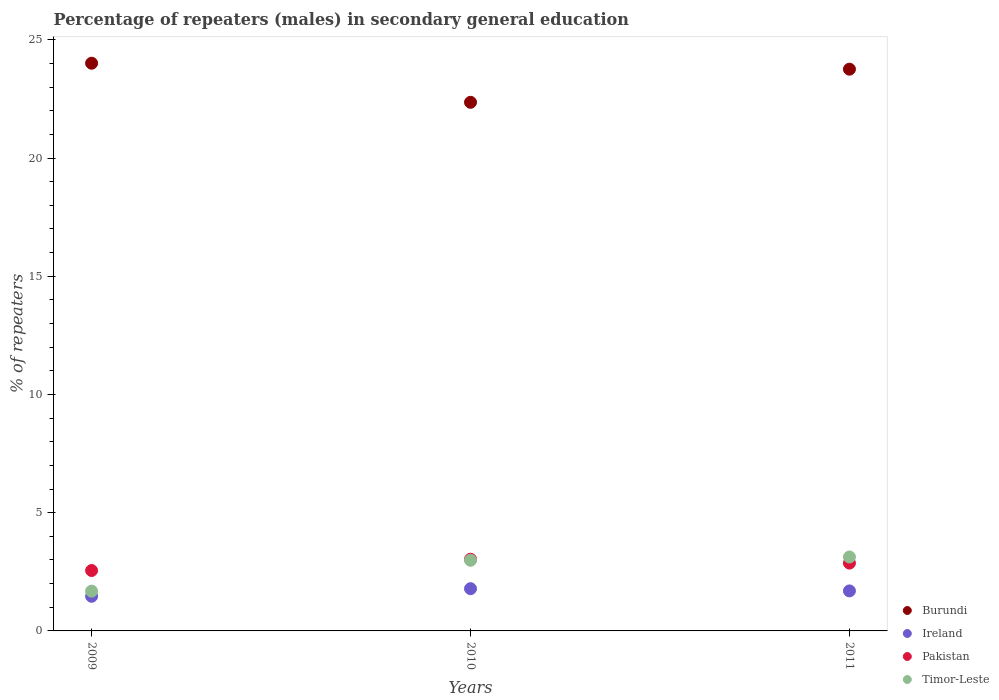How many different coloured dotlines are there?
Your answer should be very brief. 4. What is the percentage of male repeaters in Burundi in 2010?
Ensure brevity in your answer.  22.36. Across all years, what is the maximum percentage of male repeaters in Burundi?
Your answer should be compact. 24.01. Across all years, what is the minimum percentage of male repeaters in Pakistan?
Provide a succinct answer. 2.55. In which year was the percentage of male repeaters in Burundi maximum?
Keep it short and to the point. 2009. In which year was the percentage of male repeaters in Burundi minimum?
Keep it short and to the point. 2010. What is the total percentage of male repeaters in Burundi in the graph?
Keep it short and to the point. 70.12. What is the difference between the percentage of male repeaters in Pakistan in 2009 and that in 2010?
Your answer should be very brief. -0.48. What is the difference between the percentage of male repeaters in Pakistan in 2011 and the percentage of male repeaters in Timor-Leste in 2010?
Keep it short and to the point. -0.12. What is the average percentage of male repeaters in Timor-Leste per year?
Provide a succinct answer. 2.6. In the year 2011, what is the difference between the percentage of male repeaters in Timor-Leste and percentage of male repeaters in Ireland?
Your answer should be very brief. 1.43. In how many years, is the percentage of male repeaters in Burundi greater than 22 %?
Provide a succinct answer. 3. What is the ratio of the percentage of male repeaters in Ireland in 2010 to that in 2011?
Provide a succinct answer. 1.06. What is the difference between the highest and the second highest percentage of male repeaters in Timor-Leste?
Your answer should be very brief. 0.14. What is the difference between the highest and the lowest percentage of male repeaters in Pakistan?
Offer a terse response. 0.48. Is it the case that in every year, the sum of the percentage of male repeaters in Ireland and percentage of male repeaters in Burundi  is greater than the sum of percentage of male repeaters in Timor-Leste and percentage of male repeaters in Pakistan?
Your answer should be very brief. Yes. Is the percentage of male repeaters in Pakistan strictly greater than the percentage of male repeaters in Ireland over the years?
Your response must be concise. Yes. Is the percentage of male repeaters in Timor-Leste strictly less than the percentage of male repeaters in Pakistan over the years?
Your answer should be compact. No. What is the difference between two consecutive major ticks on the Y-axis?
Your answer should be compact. 5. Are the values on the major ticks of Y-axis written in scientific E-notation?
Offer a very short reply. No. Where does the legend appear in the graph?
Offer a very short reply. Bottom right. How many legend labels are there?
Your answer should be compact. 4. How are the legend labels stacked?
Your response must be concise. Vertical. What is the title of the graph?
Offer a very short reply. Percentage of repeaters (males) in secondary general education. What is the label or title of the X-axis?
Your answer should be compact. Years. What is the label or title of the Y-axis?
Your answer should be very brief. % of repeaters. What is the % of repeaters of Burundi in 2009?
Make the answer very short. 24.01. What is the % of repeaters of Ireland in 2009?
Offer a very short reply. 1.46. What is the % of repeaters of Pakistan in 2009?
Offer a very short reply. 2.55. What is the % of repeaters of Timor-Leste in 2009?
Keep it short and to the point. 1.68. What is the % of repeaters of Burundi in 2010?
Make the answer very short. 22.36. What is the % of repeaters of Ireland in 2010?
Provide a short and direct response. 1.79. What is the % of repeaters in Pakistan in 2010?
Offer a very short reply. 3.03. What is the % of repeaters in Timor-Leste in 2010?
Your response must be concise. 2.99. What is the % of repeaters in Burundi in 2011?
Give a very brief answer. 23.76. What is the % of repeaters of Ireland in 2011?
Your answer should be very brief. 1.69. What is the % of repeaters in Pakistan in 2011?
Offer a very short reply. 2.87. What is the % of repeaters of Timor-Leste in 2011?
Keep it short and to the point. 3.13. Across all years, what is the maximum % of repeaters of Burundi?
Your response must be concise. 24.01. Across all years, what is the maximum % of repeaters of Ireland?
Provide a succinct answer. 1.79. Across all years, what is the maximum % of repeaters in Pakistan?
Your answer should be very brief. 3.03. Across all years, what is the maximum % of repeaters in Timor-Leste?
Offer a very short reply. 3.13. Across all years, what is the minimum % of repeaters of Burundi?
Provide a short and direct response. 22.36. Across all years, what is the minimum % of repeaters in Ireland?
Your response must be concise. 1.46. Across all years, what is the minimum % of repeaters of Pakistan?
Ensure brevity in your answer.  2.55. Across all years, what is the minimum % of repeaters in Timor-Leste?
Provide a short and direct response. 1.68. What is the total % of repeaters in Burundi in the graph?
Your answer should be compact. 70.12. What is the total % of repeaters in Ireland in the graph?
Make the answer very short. 4.94. What is the total % of repeaters of Pakistan in the graph?
Offer a terse response. 8.45. What is the total % of repeaters in Timor-Leste in the graph?
Your response must be concise. 7.8. What is the difference between the % of repeaters in Burundi in 2009 and that in 2010?
Ensure brevity in your answer.  1.65. What is the difference between the % of repeaters of Ireland in 2009 and that in 2010?
Offer a terse response. -0.32. What is the difference between the % of repeaters of Pakistan in 2009 and that in 2010?
Give a very brief answer. -0.48. What is the difference between the % of repeaters in Timor-Leste in 2009 and that in 2010?
Ensure brevity in your answer.  -1.3. What is the difference between the % of repeaters of Burundi in 2009 and that in 2011?
Your answer should be compact. 0.25. What is the difference between the % of repeaters in Ireland in 2009 and that in 2011?
Your answer should be compact. -0.23. What is the difference between the % of repeaters in Pakistan in 2009 and that in 2011?
Your response must be concise. -0.31. What is the difference between the % of repeaters in Timor-Leste in 2009 and that in 2011?
Your answer should be very brief. -1.44. What is the difference between the % of repeaters in Burundi in 2010 and that in 2011?
Offer a very short reply. -1.4. What is the difference between the % of repeaters of Ireland in 2010 and that in 2011?
Give a very brief answer. 0.09. What is the difference between the % of repeaters of Pakistan in 2010 and that in 2011?
Your response must be concise. 0.16. What is the difference between the % of repeaters of Timor-Leste in 2010 and that in 2011?
Your answer should be very brief. -0.14. What is the difference between the % of repeaters of Burundi in 2009 and the % of repeaters of Ireland in 2010?
Your answer should be compact. 22.22. What is the difference between the % of repeaters of Burundi in 2009 and the % of repeaters of Pakistan in 2010?
Provide a succinct answer. 20.98. What is the difference between the % of repeaters in Burundi in 2009 and the % of repeaters in Timor-Leste in 2010?
Offer a terse response. 21.02. What is the difference between the % of repeaters in Ireland in 2009 and the % of repeaters in Pakistan in 2010?
Your answer should be compact. -1.57. What is the difference between the % of repeaters of Ireland in 2009 and the % of repeaters of Timor-Leste in 2010?
Offer a terse response. -1.52. What is the difference between the % of repeaters of Pakistan in 2009 and the % of repeaters of Timor-Leste in 2010?
Provide a short and direct response. -0.43. What is the difference between the % of repeaters in Burundi in 2009 and the % of repeaters in Ireland in 2011?
Offer a terse response. 22.32. What is the difference between the % of repeaters of Burundi in 2009 and the % of repeaters of Pakistan in 2011?
Ensure brevity in your answer.  21.14. What is the difference between the % of repeaters of Burundi in 2009 and the % of repeaters of Timor-Leste in 2011?
Your answer should be very brief. 20.88. What is the difference between the % of repeaters in Ireland in 2009 and the % of repeaters in Pakistan in 2011?
Give a very brief answer. -1.4. What is the difference between the % of repeaters in Ireland in 2009 and the % of repeaters in Timor-Leste in 2011?
Give a very brief answer. -1.66. What is the difference between the % of repeaters of Pakistan in 2009 and the % of repeaters of Timor-Leste in 2011?
Your response must be concise. -0.57. What is the difference between the % of repeaters in Burundi in 2010 and the % of repeaters in Ireland in 2011?
Your response must be concise. 20.66. What is the difference between the % of repeaters in Burundi in 2010 and the % of repeaters in Pakistan in 2011?
Your answer should be compact. 19.49. What is the difference between the % of repeaters of Burundi in 2010 and the % of repeaters of Timor-Leste in 2011?
Your answer should be compact. 19.23. What is the difference between the % of repeaters of Ireland in 2010 and the % of repeaters of Pakistan in 2011?
Ensure brevity in your answer.  -1.08. What is the difference between the % of repeaters in Ireland in 2010 and the % of repeaters in Timor-Leste in 2011?
Your response must be concise. -1.34. What is the difference between the % of repeaters in Pakistan in 2010 and the % of repeaters in Timor-Leste in 2011?
Keep it short and to the point. -0.1. What is the average % of repeaters of Burundi per year?
Provide a short and direct response. 23.37. What is the average % of repeaters in Ireland per year?
Offer a terse response. 1.65. What is the average % of repeaters of Pakistan per year?
Provide a succinct answer. 2.82. What is the average % of repeaters in Timor-Leste per year?
Your answer should be compact. 2.6. In the year 2009, what is the difference between the % of repeaters in Burundi and % of repeaters in Ireland?
Make the answer very short. 22.54. In the year 2009, what is the difference between the % of repeaters in Burundi and % of repeaters in Pakistan?
Offer a terse response. 21.45. In the year 2009, what is the difference between the % of repeaters in Burundi and % of repeaters in Timor-Leste?
Make the answer very short. 22.33. In the year 2009, what is the difference between the % of repeaters in Ireland and % of repeaters in Pakistan?
Provide a succinct answer. -1.09. In the year 2009, what is the difference between the % of repeaters of Ireland and % of repeaters of Timor-Leste?
Provide a short and direct response. -0.22. In the year 2009, what is the difference between the % of repeaters of Pakistan and % of repeaters of Timor-Leste?
Give a very brief answer. 0.87. In the year 2010, what is the difference between the % of repeaters in Burundi and % of repeaters in Ireland?
Provide a succinct answer. 20.57. In the year 2010, what is the difference between the % of repeaters in Burundi and % of repeaters in Pakistan?
Ensure brevity in your answer.  19.32. In the year 2010, what is the difference between the % of repeaters of Burundi and % of repeaters of Timor-Leste?
Provide a short and direct response. 19.37. In the year 2010, what is the difference between the % of repeaters in Ireland and % of repeaters in Pakistan?
Ensure brevity in your answer.  -1.25. In the year 2010, what is the difference between the % of repeaters in Ireland and % of repeaters in Timor-Leste?
Make the answer very short. -1.2. In the year 2010, what is the difference between the % of repeaters of Pakistan and % of repeaters of Timor-Leste?
Your answer should be very brief. 0.04. In the year 2011, what is the difference between the % of repeaters of Burundi and % of repeaters of Ireland?
Provide a succinct answer. 22.07. In the year 2011, what is the difference between the % of repeaters in Burundi and % of repeaters in Pakistan?
Ensure brevity in your answer.  20.89. In the year 2011, what is the difference between the % of repeaters of Burundi and % of repeaters of Timor-Leste?
Offer a terse response. 20.63. In the year 2011, what is the difference between the % of repeaters in Ireland and % of repeaters in Pakistan?
Your answer should be very brief. -1.18. In the year 2011, what is the difference between the % of repeaters of Ireland and % of repeaters of Timor-Leste?
Keep it short and to the point. -1.43. In the year 2011, what is the difference between the % of repeaters in Pakistan and % of repeaters in Timor-Leste?
Offer a very short reply. -0.26. What is the ratio of the % of repeaters of Burundi in 2009 to that in 2010?
Your answer should be compact. 1.07. What is the ratio of the % of repeaters of Ireland in 2009 to that in 2010?
Give a very brief answer. 0.82. What is the ratio of the % of repeaters of Pakistan in 2009 to that in 2010?
Make the answer very short. 0.84. What is the ratio of the % of repeaters in Timor-Leste in 2009 to that in 2010?
Your response must be concise. 0.56. What is the ratio of the % of repeaters in Burundi in 2009 to that in 2011?
Provide a succinct answer. 1.01. What is the ratio of the % of repeaters of Ireland in 2009 to that in 2011?
Offer a very short reply. 0.87. What is the ratio of the % of repeaters in Pakistan in 2009 to that in 2011?
Provide a short and direct response. 0.89. What is the ratio of the % of repeaters of Timor-Leste in 2009 to that in 2011?
Provide a short and direct response. 0.54. What is the ratio of the % of repeaters in Burundi in 2010 to that in 2011?
Offer a very short reply. 0.94. What is the ratio of the % of repeaters of Ireland in 2010 to that in 2011?
Offer a terse response. 1.06. What is the ratio of the % of repeaters in Pakistan in 2010 to that in 2011?
Keep it short and to the point. 1.06. What is the ratio of the % of repeaters in Timor-Leste in 2010 to that in 2011?
Offer a very short reply. 0.96. What is the difference between the highest and the second highest % of repeaters in Burundi?
Provide a succinct answer. 0.25. What is the difference between the highest and the second highest % of repeaters of Ireland?
Give a very brief answer. 0.09. What is the difference between the highest and the second highest % of repeaters in Pakistan?
Give a very brief answer. 0.16. What is the difference between the highest and the second highest % of repeaters in Timor-Leste?
Offer a terse response. 0.14. What is the difference between the highest and the lowest % of repeaters of Burundi?
Your answer should be very brief. 1.65. What is the difference between the highest and the lowest % of repeaters of Ireland?
Provide a short and direct response. 0.32. What is the difference between the highest and the lowest % of repeaters in Pakistan?
Your response must be concise. 0.48. What is the difference between the highest and the lowest % of repeaters of Timor-Leste?
Your response must be concise. 1.44. 